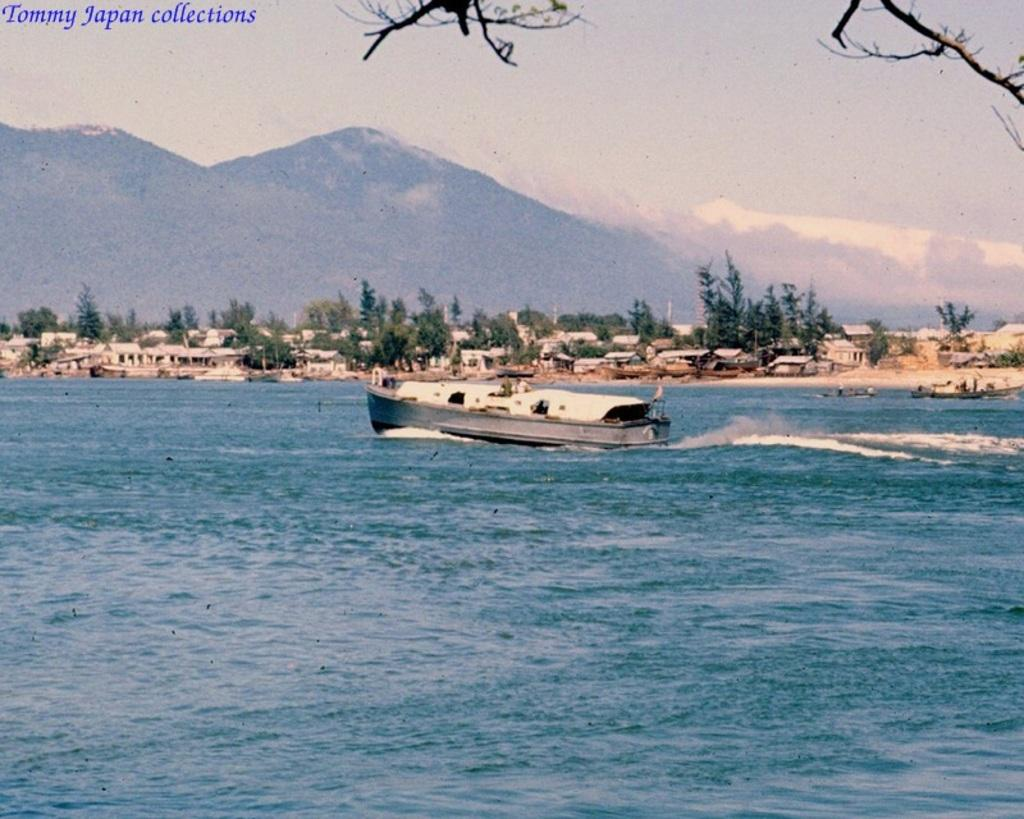What is the main subject of the image? The main subject of the image is a boat. Where is the boat located? The boat is on the water. What can be seen in the background of the image? There are trees, buildings, and mountains visible in the image. What color is the dinner served on the boat in the image? There is no dinner present in the image, so it is not possible to determine its color. 